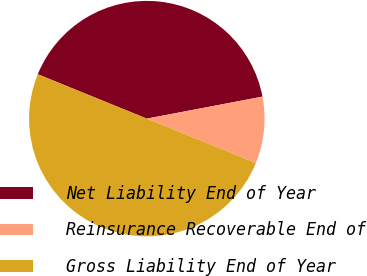Convert chart. <chart><loc_0><loc_0><loc_500><loc_500><pie_chart><fcel>Net Liability End of Year<fcel>Reinsurance Recoverable End of<fcel>Gross Liability End of Year<nl><fcel>40.85%<fcel>9.15%<fcel>50.0%<nl></chart> 